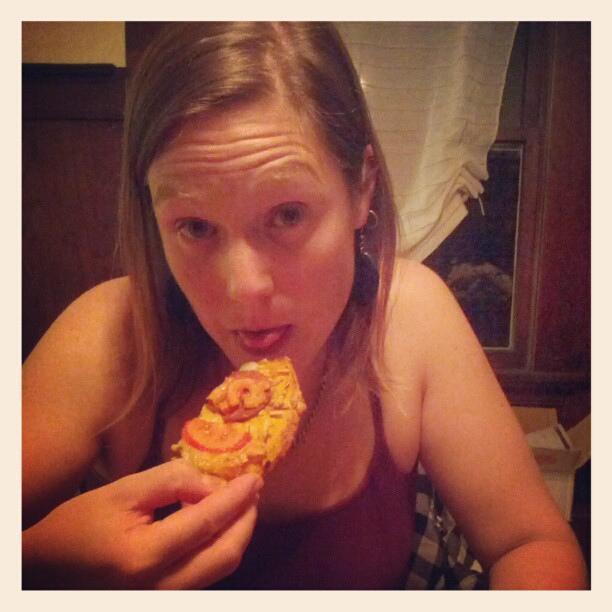How many beds are under the lamp?
Give a very brief answer. 0. 